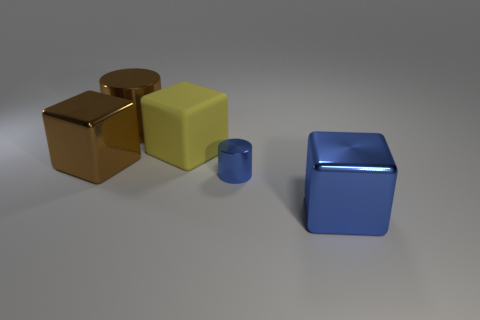Add 3 tiny purple metal things. How many objects exist? 8 Subtract all cylinders. How many objects are left? 3 Add 3 shiny cubes. How many shiny cubes are left? 5 Add 3 small objects. How many small objects exist? 4 Subtract 0 purple cylinders. How many objects are left? 5 Subtract all yellow matte objects. Subtract all brown matte balls. How many objects are left? 4 